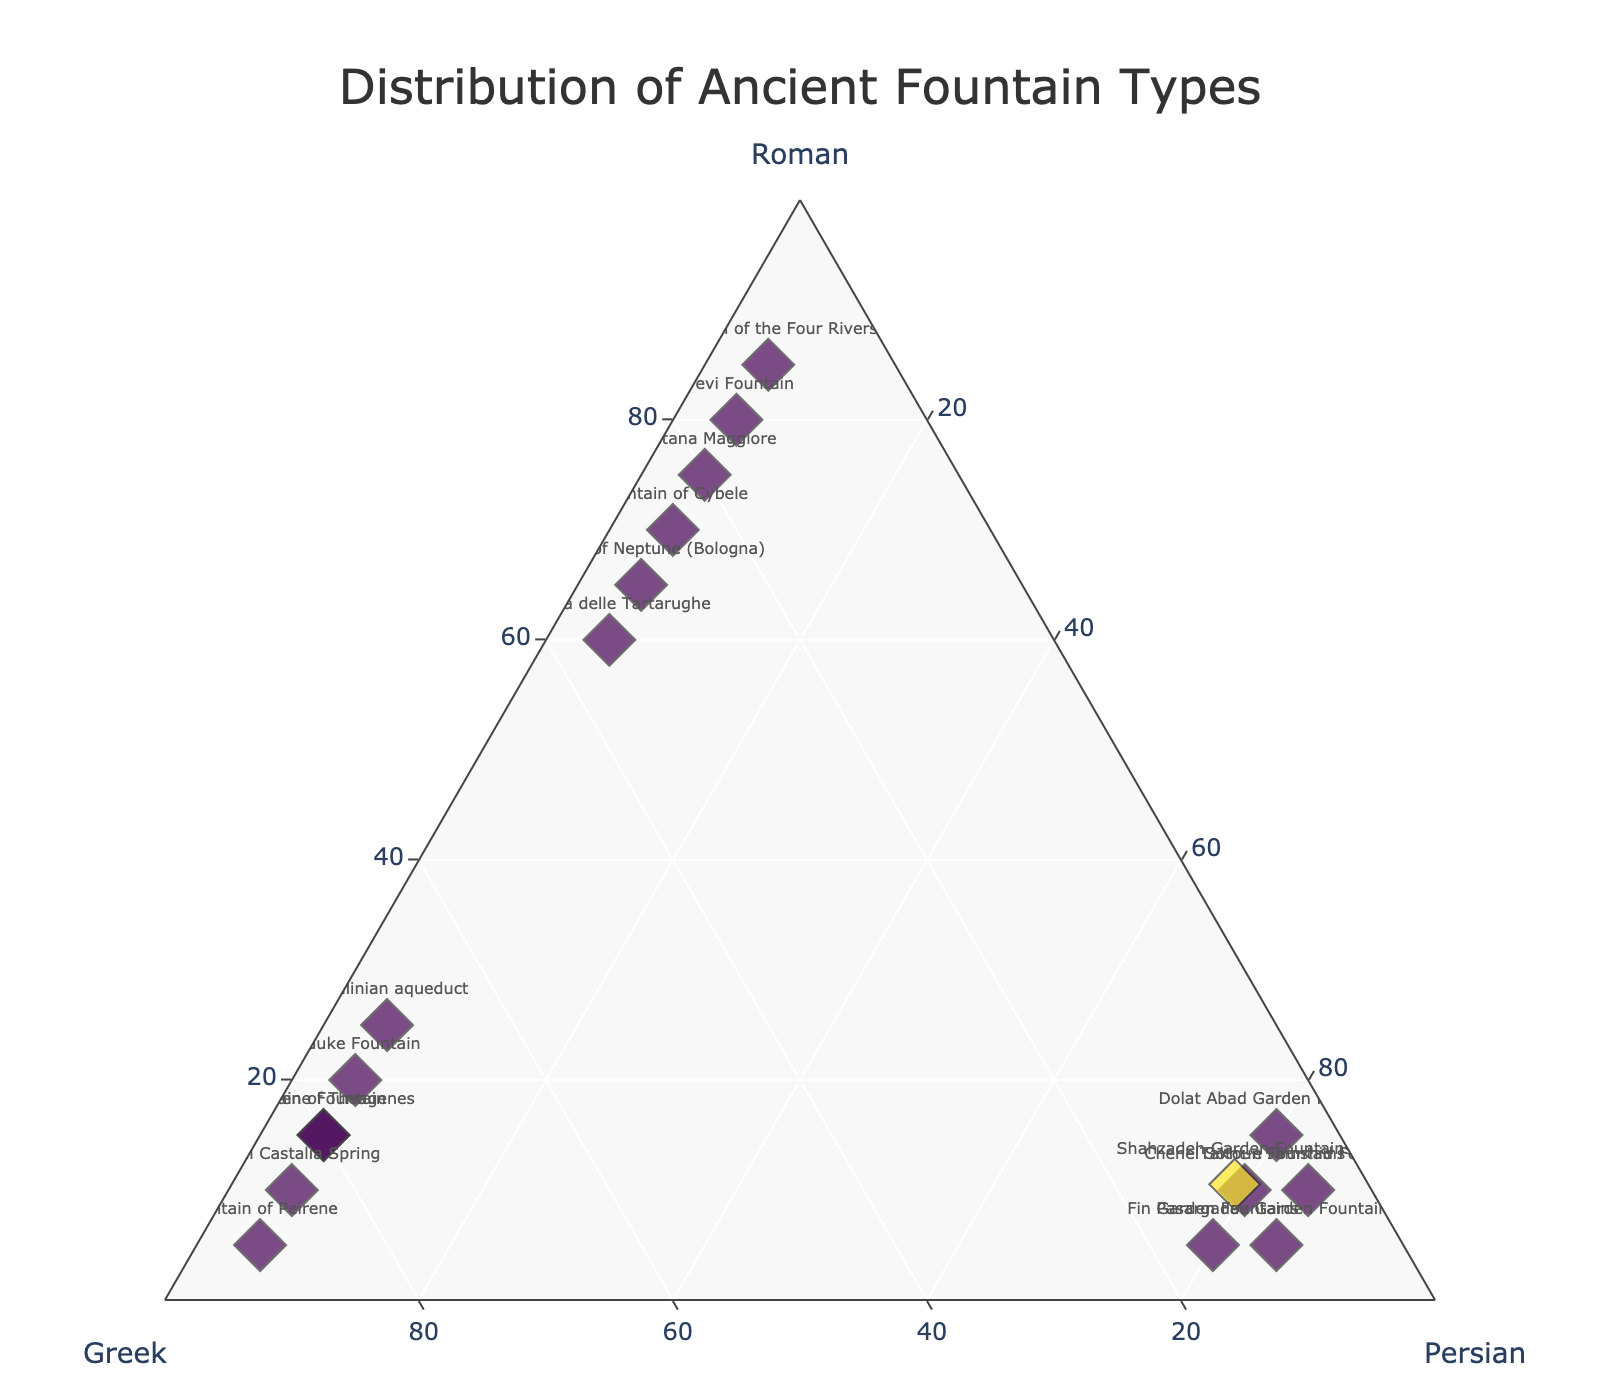How many different types of fountains are included in the plot? To determine the number of different types of fountains in the plot, count the unique names listed. Each unique name represents a different type of fountain.
Answer: 18 What is the dominant civilization for the majority of fountains? Examine the data points to see which civilization (Roman, Greek, Persian) consistently has higher percentages across more fountains. This involves comparing the proportions for each fountain.
Answer: Roman Which fountains have an equal contribution from two civilizations? Look for fountains where any two civilizations have the same percentage values. This is visually represented when two values are equal for any given fountain.
Answer: None What is the approximate size of the largest marker on the plot? The size of the markers is computed as the square root of the sum of the Roman, Greek, and Persian contributions, all multiplied by 2. Identify the marker with the largest size visually or computationally.
Answer: Approximately 21.9 Which fountain is the most influenced by the Greek civilization? Compare the Greek percentage values across all fountains and identify the one with the highest percentage.
Answer: Fountain of Peirene Do any fountains have precisely equal contributions from all three civilizations? Look for any data points where the Roman, Greek, and Persian percentages are the same. This requires checking the values for equality across the three civilizations.
Answer: No How many fountains have more than 50% contribution from any civilization? Identify fountains where the percentage for Roman, Greek, or Persian is greater than 50%. Count the number of such fountains.
Answer: 11 Which civilization has the least influence on the Pasargadae Garden Fountains? Examine the percentage values for Roman, Greek, and Persian contributions to the Pasargadae Garden Fountains and identify the lowest percentage.
Answer: Greek Is there any fountain with more than 85% contribution from any civilization? Look through the percentage values and check if any data point exceeds 85% for Roman, Greek, or Persian contributions. This involves finding values surpassing 85%.
Answer: Yes Which fountains are closest to having an equal distribution among the three civilizations? Identify fountains where the contributions from Roman, Greek, and Persian civilizations are the most balanced or closest to each other.
Answer: Trevi Fountain 